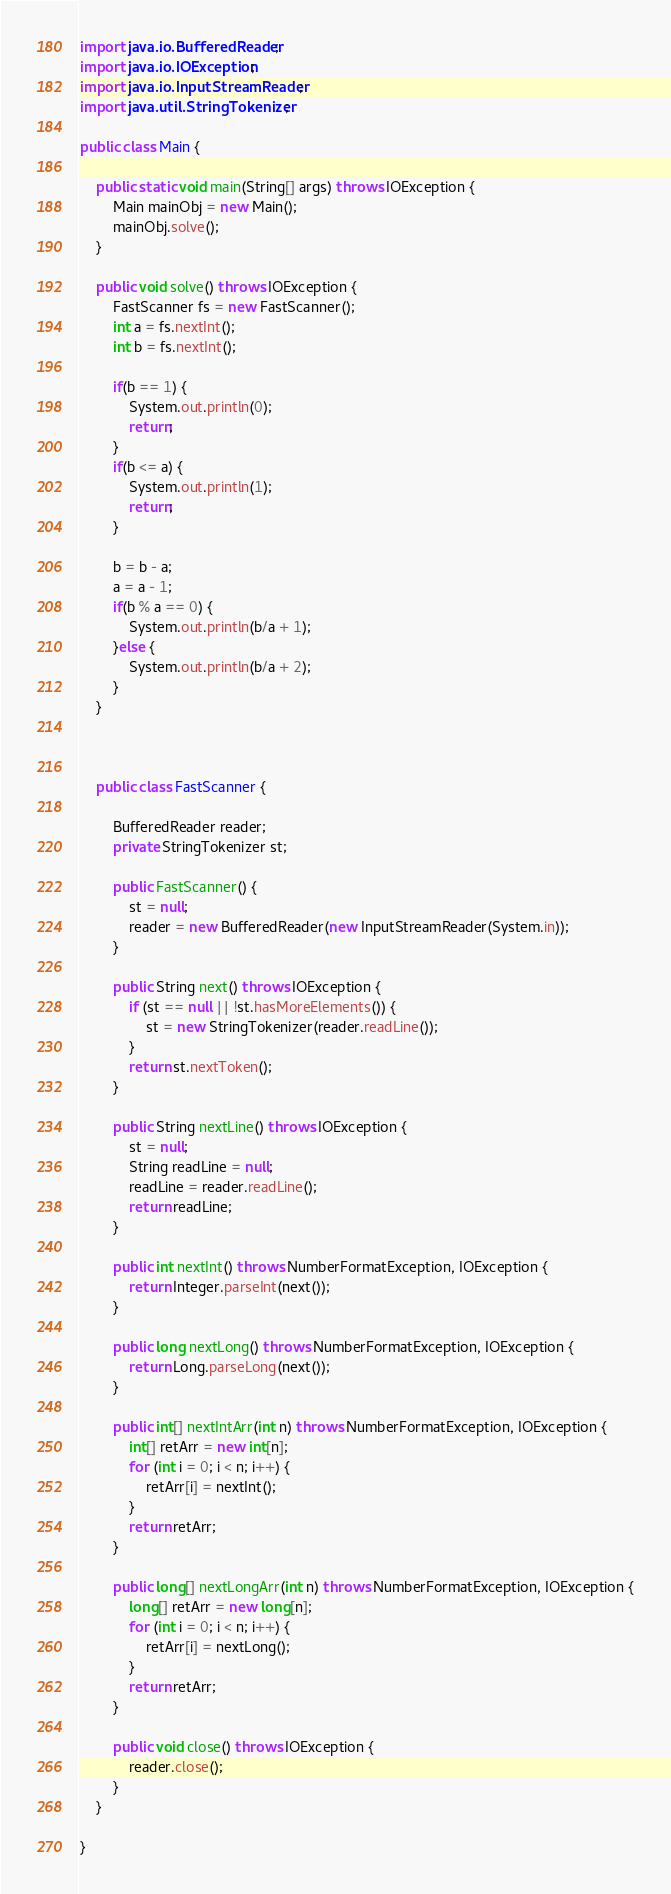<code> <loc_0><loc_0><loc_500><loc_500><_Java_>import java.io.BufferedReader;
import java.io.IOException;
import java.io.InputStreamReader;
import java.util.StringTokenizer;

public class Main {

	public static void main(String[] args) throws IOException {
		Main mainObj = new Main();
		mainObj.solve();
	}

	public void solve() throws IOException {
		FastScanner fs = new FastScanner();
		int a = fs.nextInt();
		int b = fs.nextInt();
		
		if(b == 1) {
			System.out.println(0);
			return;
		}
		if(b <= a) {
			System.out.println(1);
			return;
		}
		
		b = b - a;
		a = a - 1;
		if(b % a == 0) {
			System.out.println(b/a + 1);
		}else {
			System.out.println(b/a + 2);
		}
	}

	

	public class FastScanner {

		BufferedReader reader;
		private StringTokenizer st;

		public FastScanner() {
			st = null;
			reader = new BufferedReader(new InputStreamReader(System.in));
		}

		public String next() throws IOException {
			if (st == null || !st.hasMoreElements()) {
				st = new StringTokenizer(reader.readLine());
			}
			return st.nextToken();
		}

		public String nextLine() throws IOException {
			st = null;
			String readLine = null;
			readLine = reader.readLine();
			return readLine;
		}

		public int nextInt() throws NumberFormatException, IOException {
			return Integer.parseInt(next());
		}

		public long nextLong() throws NumberFormatException, IOException {
			return Long.parseLong(next());
		}

		public int[] nextIntArr(int n) throws NumberFormatException, IOException {
			int[] retArr = new int[n];
			for (int i = 0; i < n; i++) {
				retArr[i] = nextInt();
			}
			return retArr;
		}

		public long[] nextLongArr(int n) throws NumberFormatException, IOException {
			long[] retArr = new long[n];
			for (int i = 0; i < n; i++) {
				retArr[i] = nextLong();
			}
			return retArr;
		}

		public void close() throws IOException {
			reader.close();
		}
	}

}
</code> 